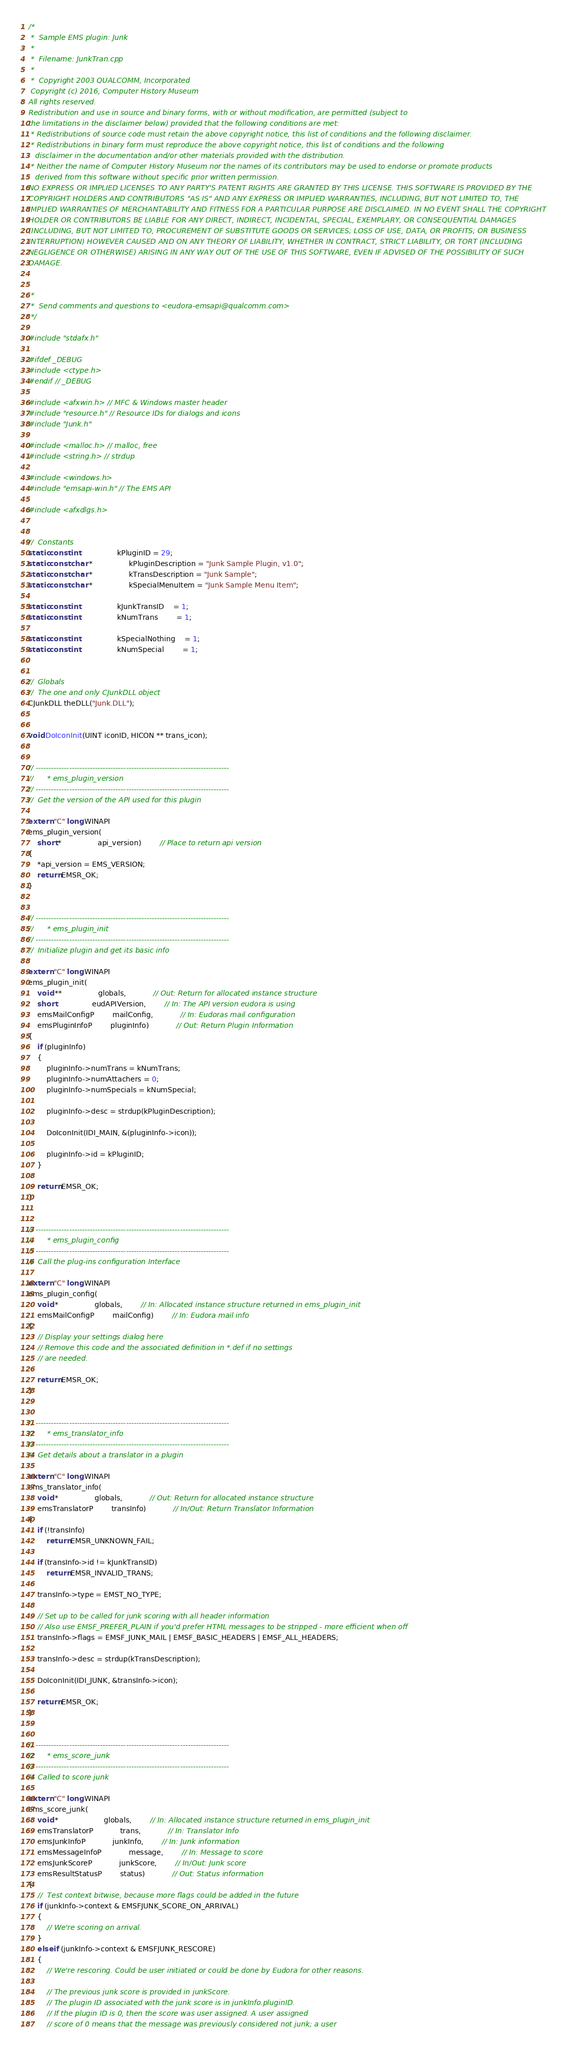Convert code to text. <code><loc_0><loc_0><loc_500><loc_500><_C++_>/*
 *  Sample EMS plugin: Junk
 *
 *  Filename: JunkTran.cpp
 *
 *  Copyright 2003 QUALCOMM, Incorporated
 Copyright (c) 2016, Computer History Museum 
All rights reserved. 
Redistribution and use in source and binary forms, with or without modification, are permitted (subject to 
the limitations in the disclaimer below) provided that the following conditions are met: 
 * Redistributions of source code must retain the above copyright notice, this list of conditions and the following disclaimer. 
 * Redistributions in binary form must reproduce the above copyright notice, this list of conditions and the following 
   disclaimer in the documentation and/or other materials provided with the distribution. 
 * Neither the name of Computer History Museum nor the names of its contributors may be used to endorse or promote products 
   derived from this software without specific prior written permission. 
NO EXPRESS OR IMPLIED LICENSES TO ANY PARTY'S PATENT RIGHTS ARE GRANTED BY THIS LICENSE. THIS SOFTWARE IS PROVIDED BY THE 
COPYRIGHT HOLDERS AND CONTRIBUTORS "AS IS" AND ANY EXPRESS OR IMPLIED WARRANTIES, INCLUDING, BUT NOT LIMITED TO, THE 
IMPLIED WARRANTIES OF MERCHANTABILITY AND FITNESS FOR A PARTICULAR PURPOSE ARE DISCLAIMED. IN NO EVENT SHALL THE COPYRIGHT 
HOLDER OR CONTRIBUTORS BE LIABLE FOR ANY DIRECT, INDIRECT, INCIDENTAL, SPECIAL, EXEMPLARY, OR CONSEQUENTIAL DAMAGES 
(INCLUDING, BUT NOT LIMITED TO, PROCUREMENT OF SUBSTITUTE GOODS OR SERVICES; LOSS OF USE, DATA, OR PROFITS; OR BUSINESS 
INTERRUPTION) HOWEVER CAUSED AND ON ANY THEORY OF LIABILITY, WHETHER IN CONTRACT, STRICT LIABILITY, OR TORT (INCLUDING 
NEGLIGENCE OR OTHERWISE) ARISING IN ANY WAY OUT OF THE USE OF THIS SOFTWARE, EVEN IF ADVISED OF THE POSSIBILITY OF SUCH 
DAMAGE. 


 *
 *  Send comments and questions to <eudora-emsapi@qualcomm.com>
 */

#include "stdafx.h"

#ifdef _DEBUG
#include <ctype.h>
#endif // _DEBUG

#include <afxwin.h> // MFC & Windows master header
#include "resource.h" // Resource IDs for dialogs and icons
#include "Junk.h" 

#include <malloc.h> // malloc, free
#include <string.h> // strdup

#include <windows.h>
#include "emsapi-win.h" // The EMS API

#include <afxdlgs.h>


//	Constants
static const int				kPluginID = 29;
static const char *				kPluginDescription = "Junk Sample Plugin, v1.0";
static const char *				kTransDescription = "Junk Sample";
static const char *				kSpecialMenuItem = "Junk Sample Menu Item";

static const int				kJunkTransID	= 1;
static const int				kNumTrans		= 1;

static const int				kSpecialNothing	= 1;
static const int				kNumSpecial		= 1;


//	Globals
//	The one and only CJunkDLL object
CJunkDLL theDLL("Junk.DLL");


void DoIconInit(UINT iconID, HICON ** trans_icon);


// ---------------------------------------------------------------------------
//		* ems_plugin_version
// ---------------------------------------------------------------------------
//	Get the version of the API used for this plugin

extern "C" long WINAPI
ems_plugin_version(
	short *				api_version)		// Place to return api version
{
	*api_version = EMS_VERSION;
	return EMSR_OK;
}


// ---------------------------------------------------------------------------
//		* ems_plugin_init
// ---------------------------------------------------------------------------
//	Initialize plugin and get its basic info

extern "C" long WINAPI
ems_plugin_init(
	void **				globals,			// Out: Return for allocated instance structure
	short				eudAPIVersion,		// In: The API version eudora is using
	emsMailConfigP		mailConfig,			// In: Eudoras mail configuration
	emsPluginInfoP		pluginInfo)			// Out: Return Plugin Information
{
	if (pluginInfo)
	{
		pluginInfo->numTrans = kNumTrans;
		pluginInfo->numAttachers = 0;
		pluginInfo->numSpecials = kNumSpecial;
		
		pluginInfo->desc = strdup(kPluginDescription);
		
		DoIconInit(IDI_MAIN, &(pluginInfo->icon));
		
		pluginInfo->id = kPluginID;
	}
	
	return EMSR_OK;
}


// ---------------------------------------------------------------------------
//		* ems_plugin_config
// ---------------------------------------------------------------------------
//	Call the plug-ins configuration Interface

extern "C" long WINAPI
ems_plugin_config(
	void *				globals,		// In: Allocated instance structure returned in ems_plugin_init
	emsMailConfigP		mailConfig)		// In: Eudora mail info
{
	// Display your settings dialog here
	// Remove this code and the associated definition in *.def if no settings
	// are needed.

	return EMSR_OK;
}


// ---------------------------------------------------------------------------
//		* ems_translator_info
// ---------------------------------------------------------------------------
//	Get details about a translator in a plugin

extern "C" long WINAPI
ems_translator_info(
	void *				globals,			// Out: Return for allocated instance structure
	emsTranslatorP		transInfo)			// In/Out: Return Translator Information
{
	if (!transInfo)
		return EMSR_UNKNOWN_FAIL;
	
	if (transInfo->id != kJunkTransID)
		return EMSR_INVALID_TRANS;

	transInfo->type = EMST_NO_TYPE;

	// Set up to be called for junk scoring with all header information
	// Also use EMSF_PREFER_PLAIN if you'd prefer HTML messages to be stripped - more efficient when off
	transInfo->flags = EMSF_JUNK_MAIL | EMSF_BASIC_HEADERS | EMSF_ALL_HEADERS;

	transInfo->desc = strdup(kTransDescription);

	DoIconInit(IDI_JUNK, &transInfo->icon);

	return EMSR_OK;
}


// ---------------------------------------------------------------------------
//		* ems_score_junk
// ---------------------------------------------------------------------------
//	Called to score junk

extern "C" long WINAPI
ems_score_junk(
	void *					globals,		// In: Allocated instance structure returned in ems_plugin_init
	emsTranslatorP			trans,			// In: Translator Info
	emsJunkInfoP			junkInfo,		// In: Junk information
	emsMessageInfoP			message,		// In: Message to score
	emsJunkScoreP			junkScore,		// In/Out: Junk score
	emsResultStatusP		status)			// Out: Status information
{
	//	Test context bitwise, because more flags could be added in the future
	if (junkInfo->context & EMSFJUNK_SCORE_ON_ARRIVAL)
	{
		// We're scoring on arrival.
	}
	else if (junkInfo->context & EMSFJUNK_RESCORE)
	{
		// We're rescoring. Could be user initiated or could be done by Eudora for other reasons.
		
		// The previous junk score is provided in junkScore.
		// The plugin ID associated with the junk score is in junkInfo.pluginID.
		// If the plugin ID is 0, then the score was user assigned. A user assigned
		// score of 0 means that the message was previously considered not junk; a user</code> 